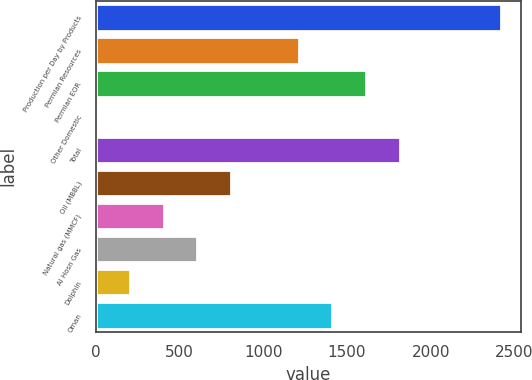<chart> <loc_0><loc_0><loc_500><loc_500><bar_chart><fcel>Production per Day by Products<fcel>Permian Resources<fcel>Permian EOR<fcel>Other Domestic<fcel>Total<fcel>Oil (MBBL)<fcel>Natural gas (MMCF)<fcel>Al Hosn Gas<fcel>Dolphin<fcel>Oman<nl><fcel>2419<fcel>1210<fcel>1613<fcel>1<fcel>1814.5<fcel>807<fcel>404<fcel>605.5<fcel>202.5<fcel>1411.5<nl></chart> 